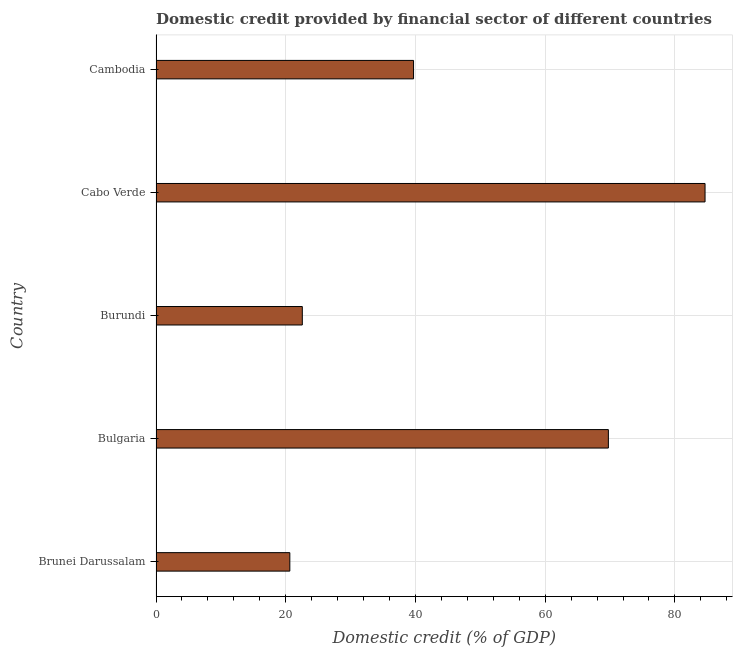What is the title of the graph?
Offer a very short reply. Domestic credit provided by financial sector of different countries. What is the label or title of the X-axis?
Your response must be concise. Domestic credit (% of GDP). What is the domestic credit provided by financial sector in Cabo Verde?
Keep it short and to the point. 84.65. Across all countries, what is the maximum domestic credit provided by financial sector?
Offer a terse response. 84.65. Across all countries, what is the minimum domestic credit provided by financial sector?
Your response must be concise. 20.63. In which country was the domestic credit provided by financial sector maximum?
Offer a terse response. Cabo Verde. In which country was the domestic credit provided by financial sector minimum?
Provide a succinct answer. Brunei Darussalam. What is the sum of the domestic credit provided by financial sector?
Provide a short and direct response. 237.29. What is the difference between the domestic credit provided by financial sector in Brunei Darussalam and Cambodia?
Make the answer very short. -19.07. What is the average domestic credit provided by financial sector per country?
Make the answer very short. 47.46. What is the median domestic credit provided by financial sector?
Make the answer very short. 39.7. In how many countries, is the domestic credit provided by financial sector greater than 48 %?
Your answer should be compact. 2. What is the ratio of the domestic credit provided by financial sector in Brunei Darussalam to that in Bulgaria?
Give a very brief answer. 0.3. Is the domestic credit provided by financial sector in Cabo Verde less than that in Cambodia?
Your answer should be very brief. No. Is the difference between the domestic credit provided by financial sector in Brunei Darussalam and Bulgaria greater than the difference between any two countries?
Your answer should be compact. No. What is the difference between the highest and the second highest domestic credit provided by financial sector?
Give a very brief answer. 14.9. Is the sum of the domestic credit provided by financial sector in Brunei Darussalam and Bulgaria greater than the maximum domestic credit provided by financial sector across all countries?
Offer a terse response. Yes. What is the difference between the highest and the lowest domestic credit provided by financial sector?
Your answer should be very brief. 64.02. How many bars are there?
Offer a terse response. 5. How many countries are there in the graph?
Your answer should be very brief. 5. Are the values on the major ticks of X-axis written in scientific E-notation?
Offer a very short reply. No. What is the Domestic credit (% of GDP) of Brunei Darussalam?
Your response must be concise. 20.63. What is the Domestic credit (% of GDP) in Bulgaria?
Offer a very short reply. 69.75. What is the Domestic credit (% of GDP) of Burundi?
Provide a succinct answer. 22.56. What is the Domestic credit (% of GDP) in Cabo Verde?
Ensure brevity in your answer.  84.65. What is the Domestic credit (% of GDP) of Cambodia?
Your answer should be very brief. 39.7. What is the difference between the Domestic credit (% of GDP) in Brunei Darussalam and Bulgaria?
Keep it short and to the point. -49.11. What is the difference between the Domestic credit (% of GDP) in Brunei Darussalam and Burundi?
Make the answer very short. -1.92. What is the difference between the Domestic credit (% of GDP) in Brunei Darussalam and Cabo Verde?
Ensure brevity in your answer.  -64.02. What is the difference between the Domestic credit (% of GDP) in Brunei Darussalam and Cambodia?
Your answer should be very brief. -19.07. What is the difference between the Domestic credit (% of GDP) in Bulgaria and Burundi?
Offer a terse response. 47.19. What is the difference between the Domestic credit (% of GDP) in Bulgaria and Cabo Verde?
Provide a succinct answer. -14.9. What is the difference between the Domestic credit (% of GDP) in Bulgaria and Cambodia?
Ensure brevity in your answer.  30.04. What is the difference between the Domestic credit (% of GDP) in Burundi and Cabo Verde?
Offer a terse response. -62.09. What is the difference between the Domestic credit (% of GDP) in Burundi and Cambodia?
Offer a terse response. -17.15. What is the difference between the Domestic credit (% of GDP) in Cabo Verde and Cambodia?
Keep it short and to the point. 44.94. What is the ratio of the Domestic credit (% of GDP) in Brunei Darussalam to that in Bulgaria?
Keep it short and to the point. 0.3. What is the ratio of the Domestic credit (% of GDP) in Brunei Darussalam to that in Burundi?
Give a very brief answer. 0.92. What is the ratio of the Domestic credit (% of GDP) in Brunei Darussalam to that in Cabo Verde?
Give a very brief answer. 0.24. What is the ratio of the Domestic credit (% of GDP) in Brunei Darussalam to that in Cambodia?
Offer a terse response. 0.52. What is the ratio of the Domestic credit (% of GDP) in Bulgaria to that in Burundi?
Give a very brief answer. 3.09. What is the ratio of the Domestic credit (% of GDP) in Bulgaria to that in Cabo Verde?
Provide a short and direct response. 0.82. What is the ratio of the Domestic credit (% of GDP) in Bulgaria to that in Cambodia?
Your response must be concise. 1.76. What is the ratio of the Domestic credit (% of GDP) in Burundi to that in Cabo Verde?
Offer a very short reply. 0.27. What is the ratio of the Domestic credit (% of GDP) in Burundi to that in Cambodia?
Make the answer very short. 0.57. What is the ratio of the Domestic credit (% of GDP) in Cabo Verde to that in Cambodia?
Your answer should be very brief. 2.13. 